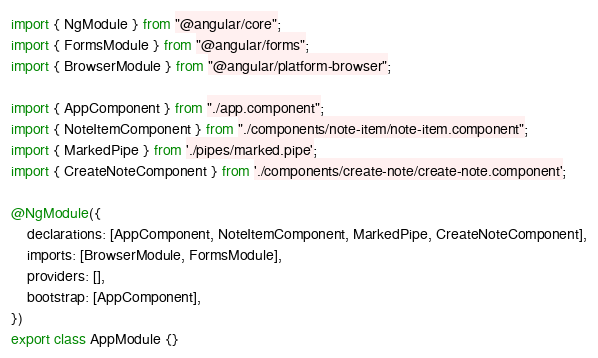<code> <loc_0><loc_0><loc_500><loc_500><_TypeScript_>import { NgModule } from "@angular/core";
import { FormsModule } from "@angular/forms";
import { BrowserModule } from "@angular/platform-browser";

import { AppComponent } from "./app.component";
import { NoteItemComponent } from "./components/note-item/note-item.component";
import { MarkedPipe } from './pipes/marked.pipe';
import { CreateNoteComponent } from './components/create-note/create-note.component';

@NgModule({
    declarations: [AppComponent, NoteItemComponent, MarkedPipe, CreateNoteComponent],
    imports: [BrowserModule, FormsModule],
    providers: [],
    bootstrap: [AppComponent],
})
export class AppModule {}
</code> 